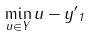Convert formula to latex. <formula><loc_0><loc_0><loc_500><loc_500>\min _ { u \in Y } \| u - y ^ { \prime } \| _ { 1 }</formula> 